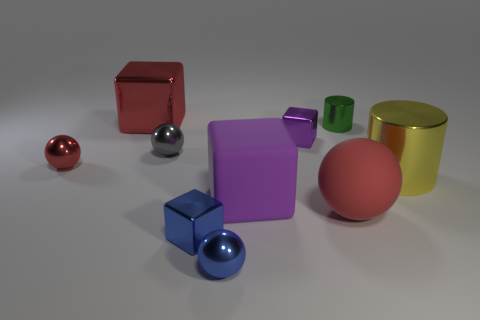Subtract 1 cubes. How many cubes are left? 3 Subtract all gray cubes. Subtract all cyan cylinders. How many cubes are left? 4 Subtract all cylinders. How many objects are left? 8 Add 10 big gray rubber cubes. How many big gray rubber cubes exist? 10 Subtract 1 red blocks. How many objects are left? 9 Subtract all cylinders. Subtract all gray things. How many objects are left? 7 Add 1 big yellow things. How many big yellow things are left? 2 